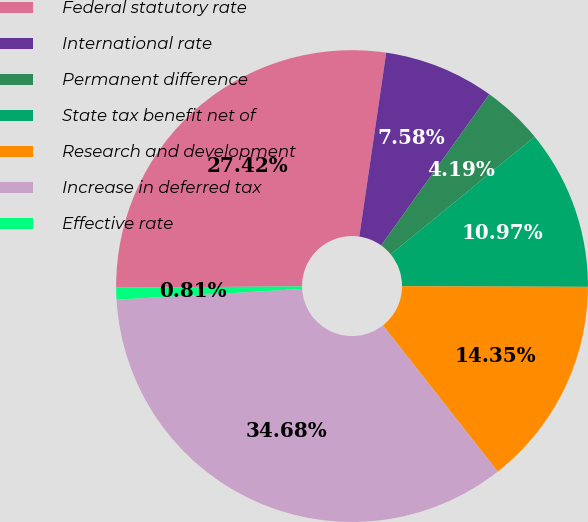Convert chart to OTSL. <chart><loc_0><loc_0><loc_500><loc_500><pie_chart><fcel>Federal statutory rate<fcel>International rate<fcel>Permanent difference<fcel>State tax benefit net of<fcel>Research and development<fcel>Increase in deferred tax<fcel>Effective rate<nl><fcel>27.42%<fcel>7.58%<fcel>4.19%<fcel>10.97%<fcel>14.35%<fcel>34.68%<fcel>0.81%<nl></chart> 